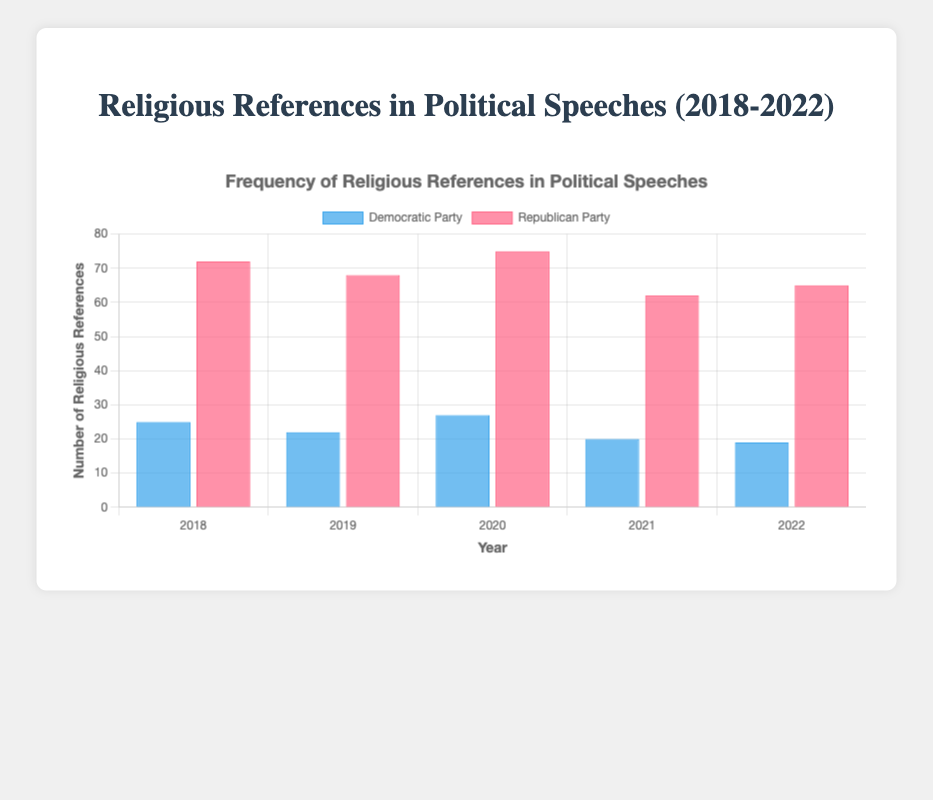What's the total number of religious references made by both parties in 2020? To find the total religious references made by both parties in 2020, add the references made by the Democratic Party (27) and the Republican Party (75). Thus, 27 + 75 = 102
Answer: 102 Which party had more religious references in 2019, and by how much? Compare the religious references made by the Democratic Party (22) and the Republican Party (68) in 2019. The Republican Party made more references. The difference is 68 - 22 = 46
Answer: Republican Party, 46 What is the average number of religious references made by the Republican Party over the five years? To find the average, sum up the references made by the Republican Party over the five years: 72 + 68 + 75 + 62 + 65 = 342. Then, divide by the number of years (5). So, the average is 342 / 5 = 68.4
Answer: 68.4 In which year did the Democratic Party make the fewest religious references? Compare the religious references made by the Democratic Party each year: 25 (2018), 22 (2019), 27 (2020), 20 (2021), 19 (2022). The fewest references were made in 2022 with 19 references
Answer: 2022 How did the number of religious references by the Democratic Party change from 2018 to 2022? The number of religious references started at 25 in 2018 and decreased to 19 in 2022. Compute the change by doing 19 - 25 = -6. This indicates a decrease of 6 references
Answer: Decreased by 6 Which year had the highest total number of religious references by both parties? For each year, sum the religious references made by both parties. 
2018: 25 + 72 = 97, 
2019: 22 + 68 = 90, 
2020: 27 + 75 = 102, 
2021: 20 + 62 = 82, 
2022: 19 + 65 = 84. 
2020 had the highest total with 102 references
Answer: 2020 What is the overall trend for religious references by the Republican Party from 2018 to 2022? Observe the trend of the reference counts: 72 (2018), 68 (2019), 75 (2020), 62 (2021), 65 (2022). Although there are slight fluctuations, the overall trend appears to be decreasing slowly
Answer: Decreasing Which party had the more consistent use of religious references over the five years? Examine the data for consistency (smaller variation year-to-year): 
Democratic Party references are 25, 22, 27, 20, 19 (variation of 8)
Republican Party references are 72, 68, 75, 62, 65 (variation of 13). The Democratic Party is more consistent
Answer: Democratic Party 